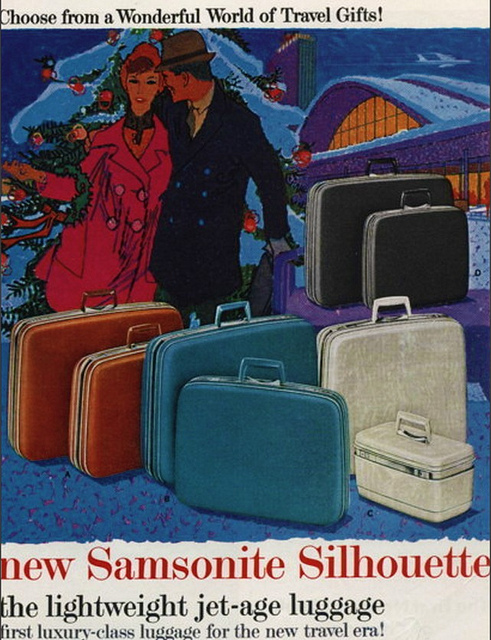What might be the occasion for the couple's travel, based on the background? Given the festive decoration and attire of the couple, it could be inferred that they are planning to travel for a holiday occasion, possibly to visit family or enjoy a winter vacation. What kind of destinations could suit the luggage style presented? The stylish and durable design of the Samsonite Silhouette luggage would be suitable for a variety of destinations, from cosmopolitan city breaks to luxurious resort stays, catering to both the practical and aesthetic needs of travelers in that era. 